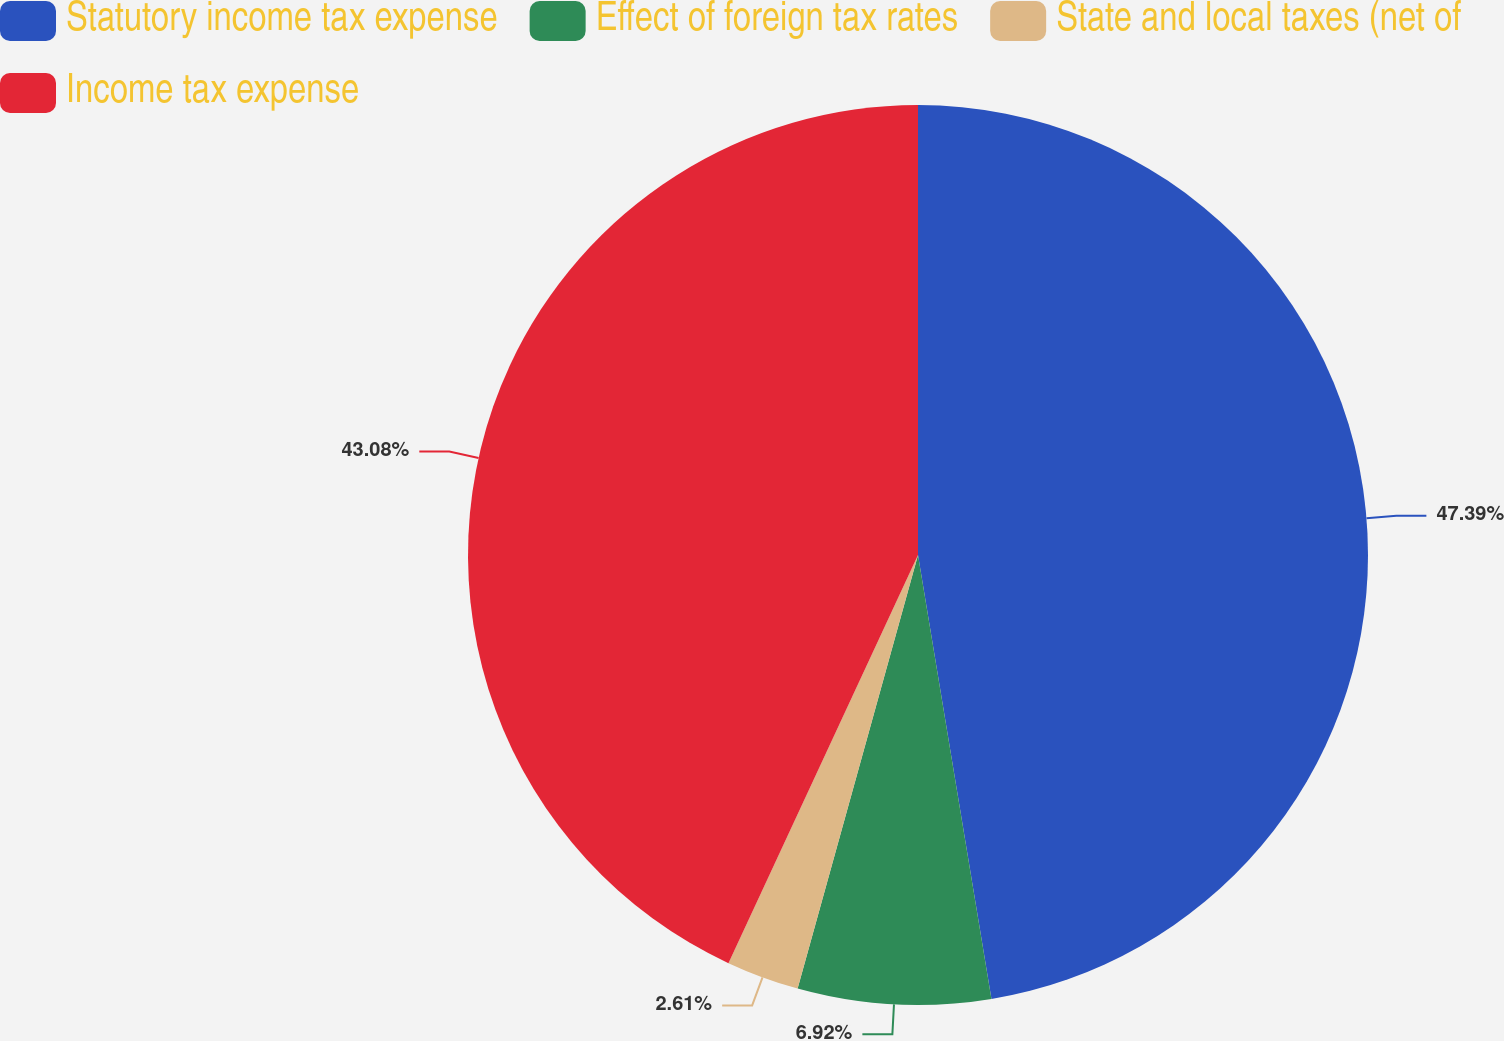Convert chart. <chart><loc_0><loc_0><loc_500><loc_500><pie_chart><fcel>Statutory income tax expense<fcel>Effect of foreign tax rates<fcel>State and local taxes (net of<fcel>Income tax expense<nl><fcel>47.39%<fcel>6.92%<fcel>2.61%<fcel>43.08%<nl></chart> 